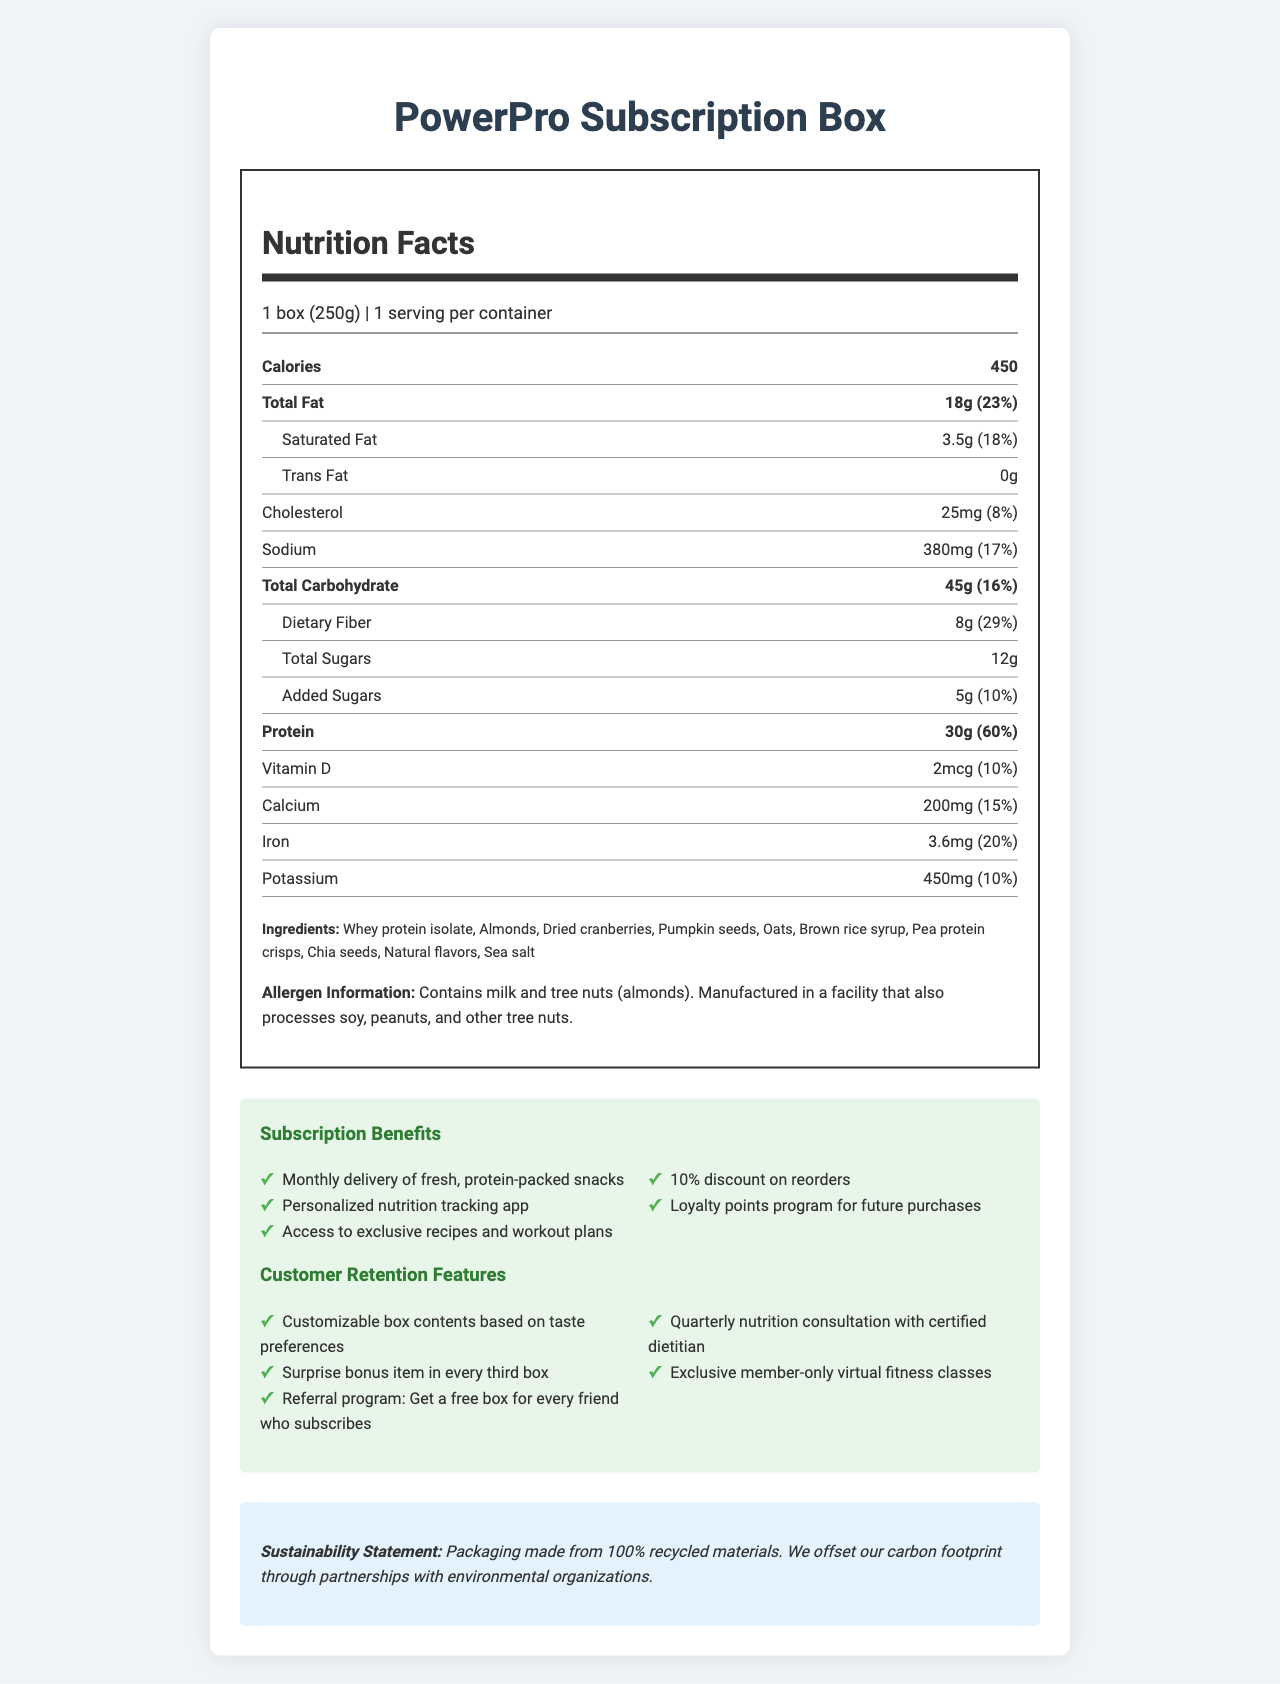how many servings are in each container? The document states that there is "1 serving per container."
Answer: 1 what is the amount of protein per serving? The document specifies that there are 30g of protein per serving.
Answer: 30g what are the primary ingredients of the PowerPro Subscription Box? The ingredients are listed in the "Ingredients" section of the document.
Answer: Whey protein isolate, Almonds, Dried cranberries, Pumpkin seeds, Oats, Brown rice syrup, Pea protein crisps, Chia seeds, Natural flavors, Sea salt Does the product contain cholesterol? The document indicates that the product contains 25mg of cholesterol, which is 8% of the daily value.
Answer: Yes which nutrient has the highest daily value percentage? The document shows that protein has a daily value percentage of 60%, which is the highest among the listed nutrients.
Answer: Protein what is the serving size of the PowerPro Subscription Box? The serving size is indicated as "1 box (250g)" in the document.
Answer: 1 box (250g) how much dietary fiber does the product contain? The document lists 8g of dietary fiber per serving.
Answer: 8g what is the daily value percentage of total fat? The document shows that the total fat is 18g, which is 23% of the daily value.
Answer: 23% Which of the following is NOT a retention feature of the PowerPro Subscription Box? 1. Customizable box contents 2. Personalized nutrition tracking app 3. Referral program 4. Surprise bonus item The personalized nutrition tracking app is a subscription benefit, not specifically a retention feature.
Answer: 2. Personalized nutrition tracking app How much calcium is in the PowerPro Subscription Box? A. 150mg B. 200mg C. 250mg D. 300mg The document states that the amount of calcium is 200mg, representing 15% of the daily value.
Answer: B. 200mg Is there any trans fat in the product? The document states that the product contains 0g of trans fat.
Answer: No how does the PowerPro Subscription Box contribute to sustainability? The sustainability statement mentions these specific actions.
Answer: Packaging made from 100% recycled materials and carbon footprint offset through partnerships with environmental organizations which of the following is an allergen present in the product? A. Soy B. Peanuts C. Tree nuts D. Wheat The document states that the product contains tree nuts (almonds).
Answer: C. Tree nuts summarize the key information about the PowerPro Subscription Box. This summary integrates all key aspects of the document including nutrition facts, ingredients, allergens, subscription benefits, customer retention features, and sustainability efforts.
Answer: The PowerPro Subscription Box is a protein-packed snack box with various health benefits. It contains a single serving of 250g, providing 450 calories, 30g protein, 18g total fat, and 45g total carbohydrates. The product includes ingredients such as whey protein isolate, almonds, and dried cranberries, and contains milk and tree nuts. Subscription benefits include monthly delivery, personalized nutrition app, exclusive recipes and workout plans, and a loyalty points program. Retention features include customizable box contents, a surprise bonus item every third box, a referral program, and quarterly consultations with a dietitian. The packaging is made from 100% recycled materials and the company offsets its carbon footprint through environmental partnerships. how does the loyalty points program benefit customers? The document mentions a loyalty points program for future purchases but doesn't provide details on how it benefits customers.
Answer: Not enough information What is the amount of sodium per serving? The document specifies that there are 380mg of sodium per serving.
Answer: 380mg 